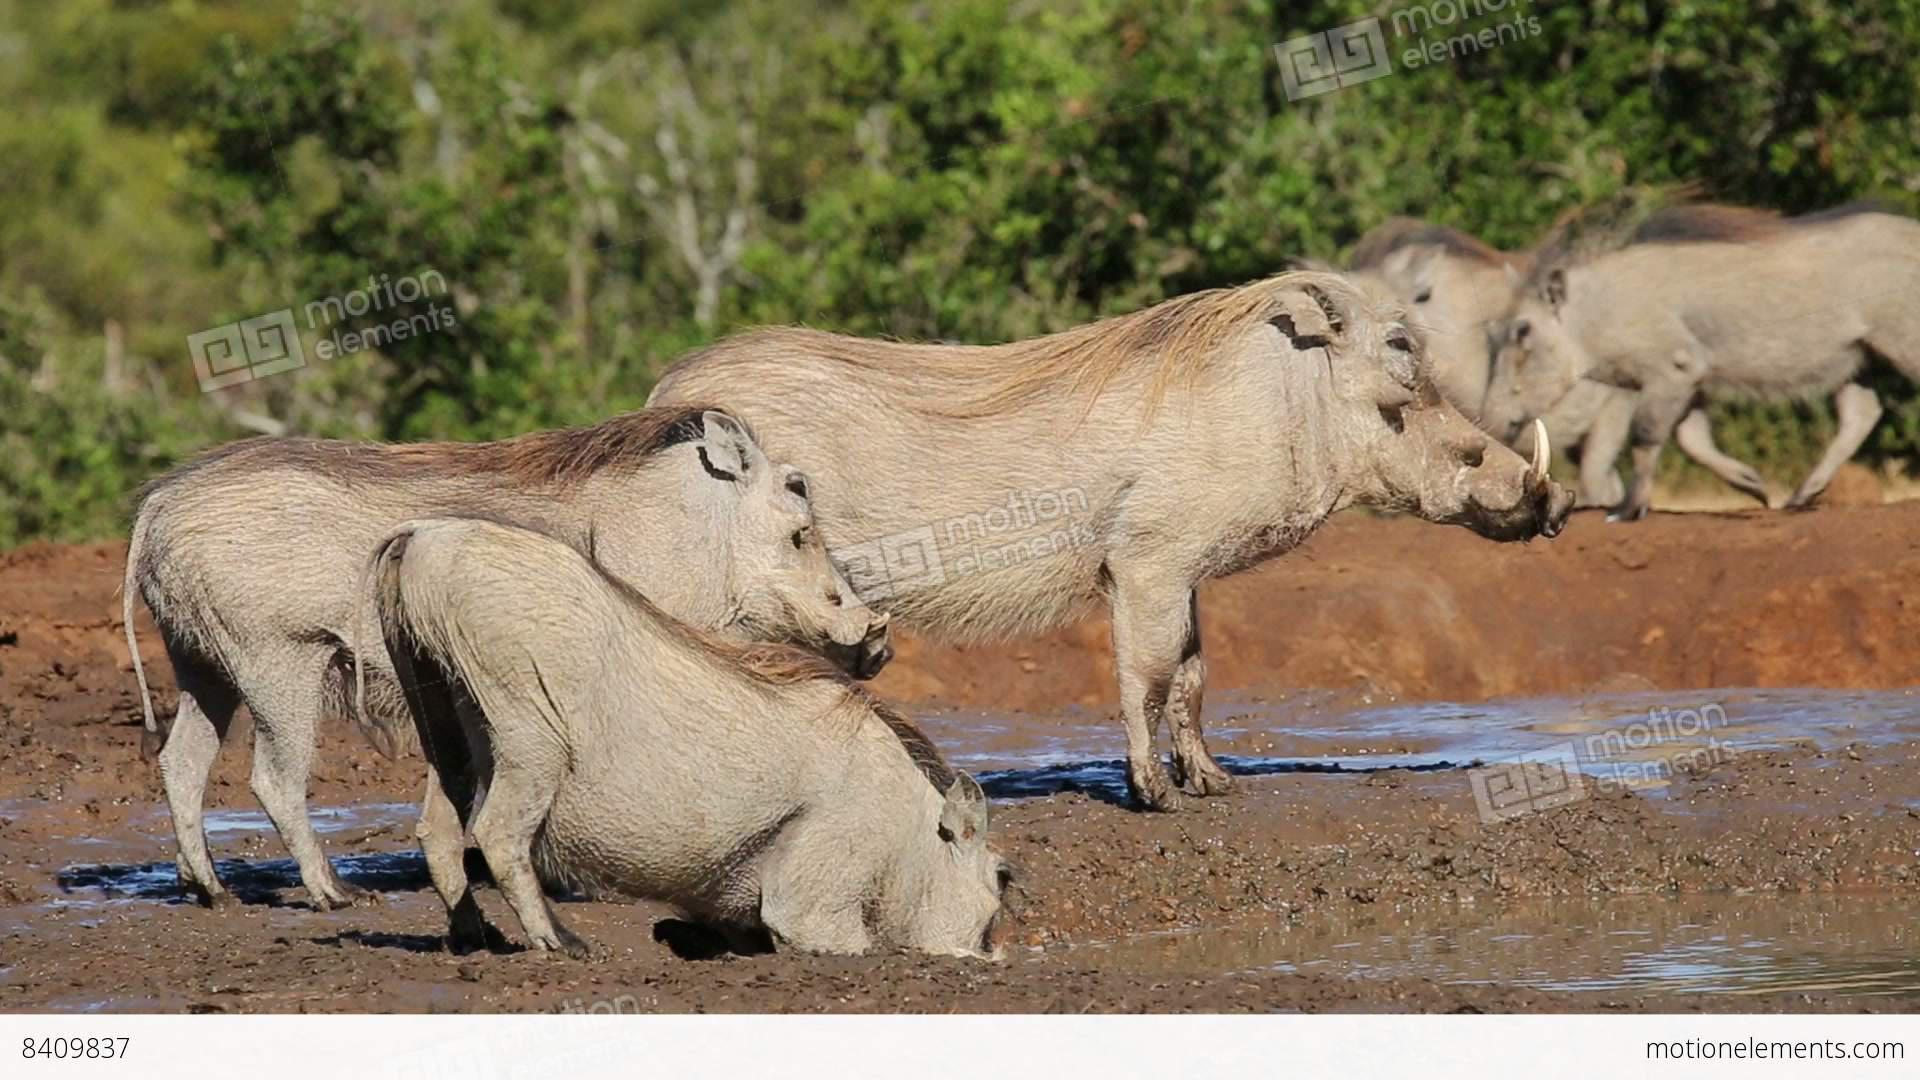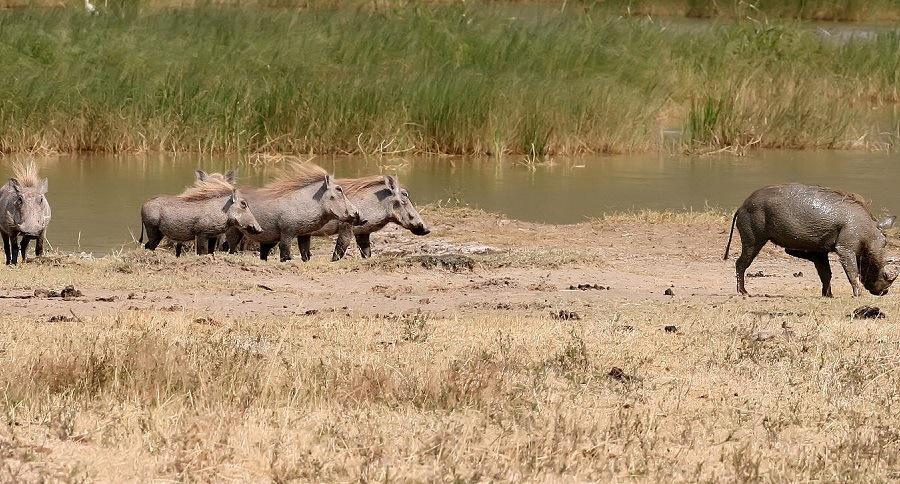The first image is the image on the left, the second image is the image on the right. Assess this claim about the two images: "There is a group of warthogs by the water.". Correct or not? Answer yes or no. Yes. The first image is the image on the left, the second image is the image on the right. Considering the images on both sides, is "In one of the images there is a group of warthogs standing near water." valid? Answer yes or no. Yes. The first image is the image on the left, the second image is the image on the right. Evaluate the accuracy of this statement regarding the images: "There are at least 5 black animals in th eimage on the left.". Is it true? Answer yes or no. No. The first image is the image on the left, the second image is the image on the right. Examine the images to the left and right. Is the description "An image shows a water source for warthogs." accurate? Answer yes or no. Yes. 